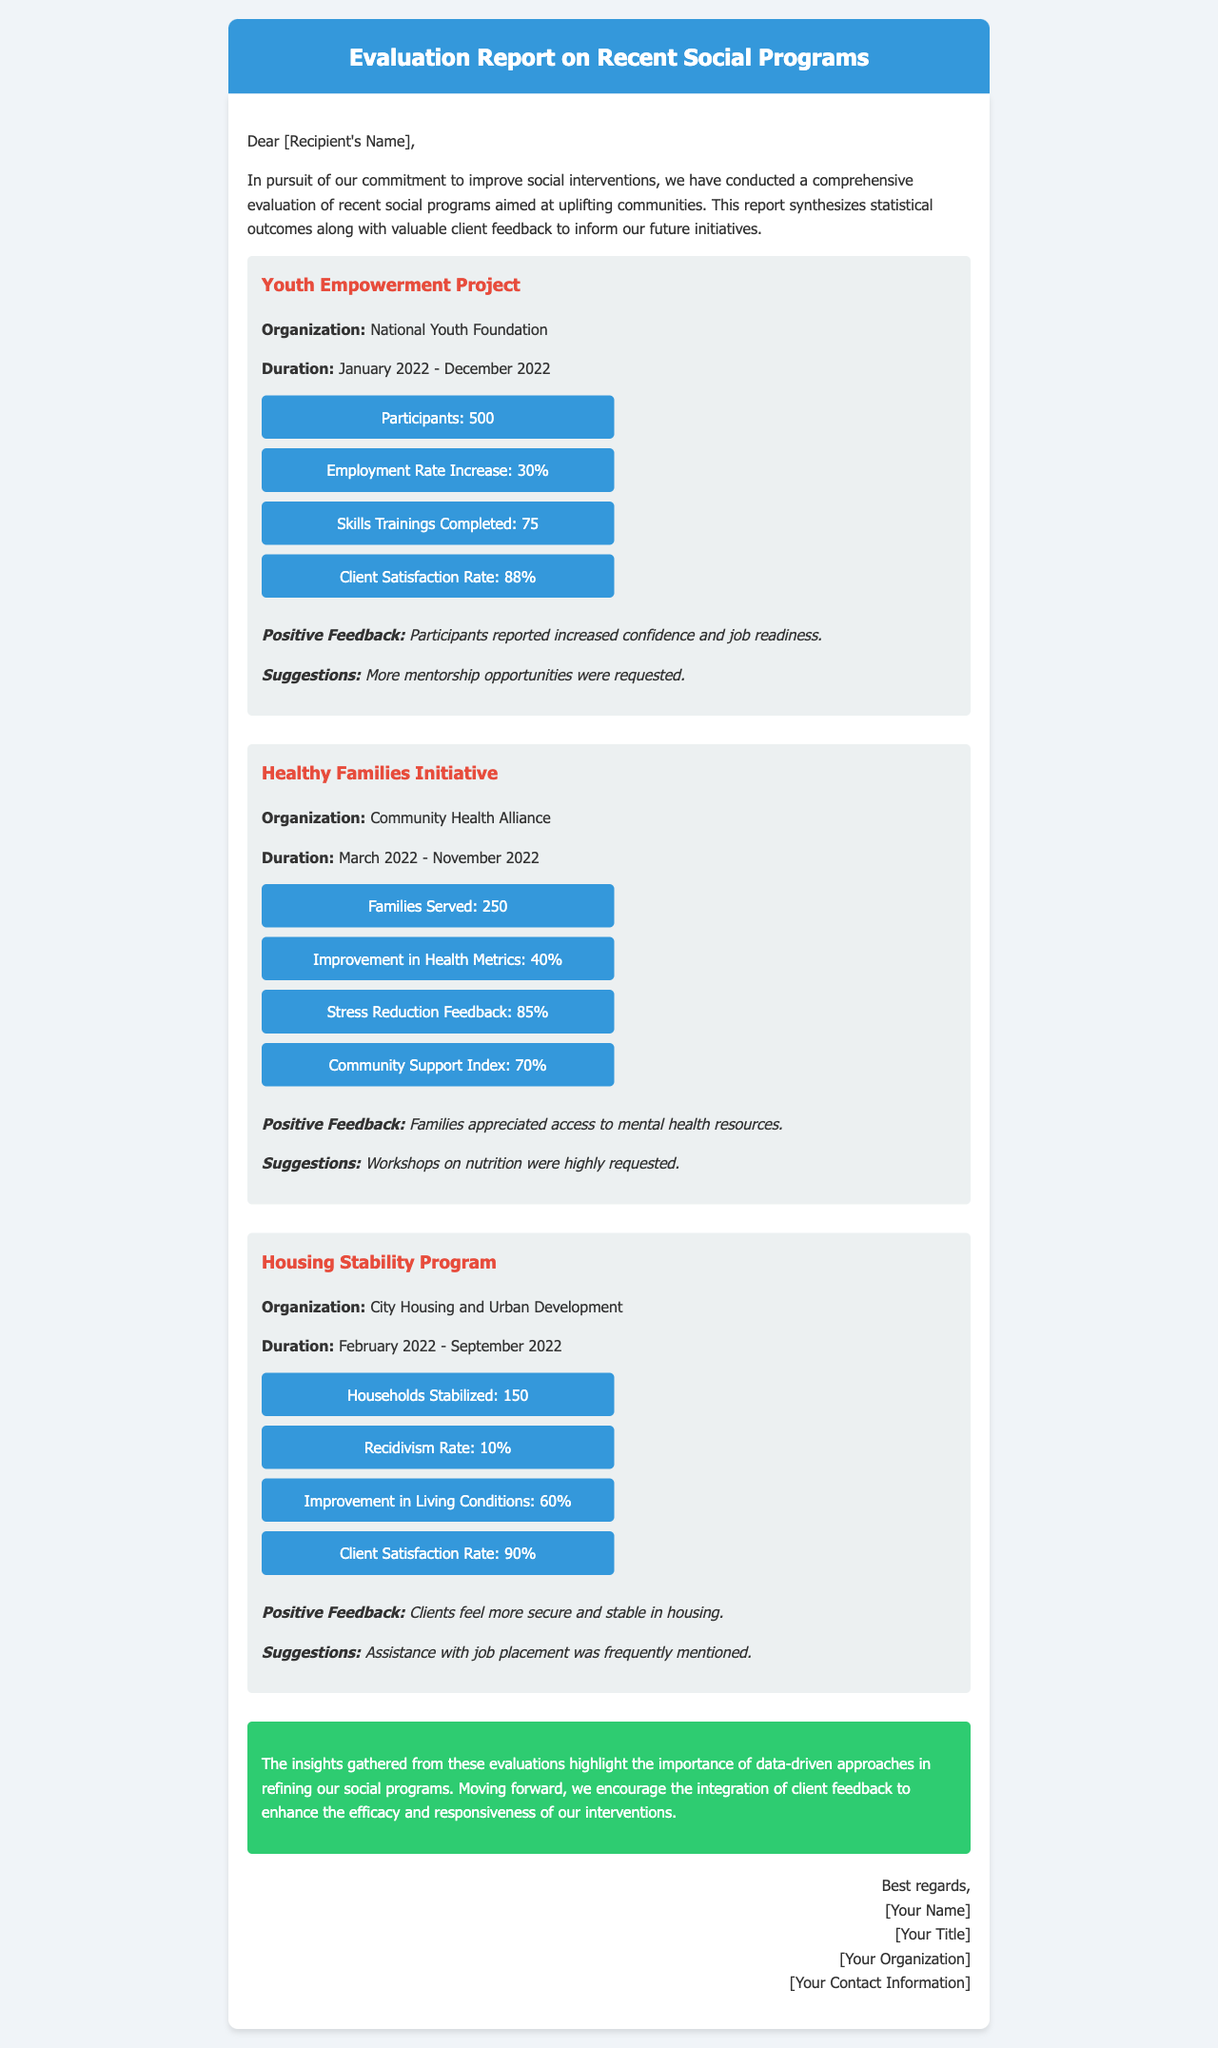What is the name of the first program evaluated? The first program evaluated is stated at the beginning of its section, which is "Youth Empowerment Project."
Answer: Youth Empowerment Project How many families were served in the Healthy Families Initiative? This information is found in the statistics for the Healthy Families Initiative, which shows "Families Served: 250."
Answer: 250 What was the improvement in health metrics for the Healthy Families Initiative? The improvement percentage for health metrics is explicitly mentioned in the document as "Improvement in Health Metrics: 40%."
Answer: 40% What is the client satisfaction rate of the Housing Stability Program? The document states the client satisfaction rate for the Housing Stability Program as "Client Satisfaction Rate: 90%."
Answer: 90% How many participants were involved in the Youth Empowerment Project? The number of participants is provided as "Participants: 500" in the Youth Empowerment Project section.
Answer: 500 What improvement percentage was reported for the Housing Stability Program's living conditions? The document notes the improvement in living conditions as "Improvement in Living Conditions: 60%."
Answer: 60% What was one of the suggestions made by participants of the Youth Empowerment Project? Among the suggestions highlighted for the Youth Empowerment Project, it mentions that "More mentorship opportunities were requested."
Answer: More mentorship opportunities What was the duration of the Healthy Families Initiative? The duration is stated in the program section as "March 2022 - November 2022."
Answer: March 2022 - November 2022 Which organization conducted the Housing Stability Program? The organization responsible for this program is given as "City Housing and Urban Development" in the relevant section.
Answer: City Housing and Urban Development 